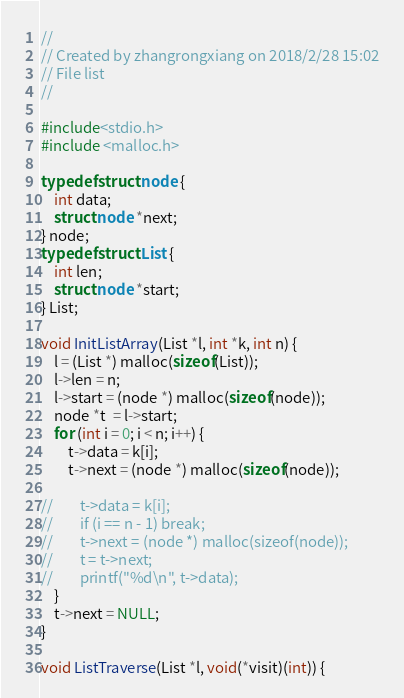<code> <loc_0><loc_0><loc_500><loc_500><_C_>//
// Created by zhangrongxiang on 2018/2/28 15:02
// File list
//

#include<stdio.h>
#include <malloc.h>

typedef struct node {
    int data;
    struct node *next;
} node;
typedef struct List {
    int len;
    struct node *start;
} List;

void InitListArray(List *l, int *k, int n) {
    l = (List *) malloc(sizeof(List));
    l->len = n;
    l->start = (node *) malloc(sizeof(node));
    node *t  = l->start;
    for (int i = 0; i < n; i++) {
        t->data = k[i];
        t->next = (node *) malloc(sizeof(node));

//        t->data = k[i];
//        if (i == n - 1) break;
//        t->next = (node *) malloc(sizeof(node));
//        t = t->next;
//        printf("%d\n", t->data);
    }
    t->next = NULL;
}

void ListTraverse(List *l, void(*visit)(int)) {</code> 